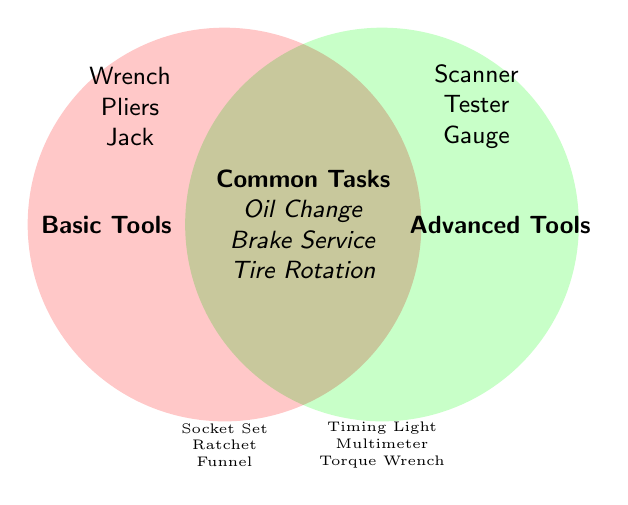Which tools are listed under Basic Tools? The tools under Basic Tools are listed on the left circle of the Venn Diagram, which are Wrench, Pliers, Jack, Socket Set, Ratchet, and Funnel.
Answer: Wrench, Pliers, Jack, Socket Set, Ratchet, Funnel Which tools are listed under Advanced Tools? The tools under Advanced Tools are listed on the right circle of the Venn Diagram, which are Diagnostic Scanner, Oscilloscope, Compression Tester, Fuel Pressure Gauge, Timing Light, Multimeter, and Torque Wrench.
Answer: Diagnostic Scanner, Oscilloscope, Compression Tester, Fuel Pressure Gauge, Timing Light, Multimeter, Torque Wrench What are the common maintenance tasks that overlap between Basic Tools and Advanced Tools? The common tasks are listed in the intersection of the two circles, which are Oil Change, Brake Service, Tire Rotation, Battery Check, Fluid Top-up, and Filter Replacement.
Answer: Oil Change, Brake Service, Tire Rotation, Battery Check, Fluid Top-up, Filter Replacement How many maintenance tasks are common between Basic Tools and Advanced Tools? Count the number of tasks in the intersection of the two circles. There are six tasks listed.
Answer: 6 What tool is required for an Oil Change? Check the common tasks listed in the intersection and match with the tools. The intersection lists Oil Change, which indicates that it requires both basic and advanced tools.
Answer: Both Basic & Advanced Tools Are there more tools listed under Basic Tools or Advanced Tools? Count the number of tools in each circle. Basic Tools have six tools; Advanced Tools have seven tools. Therefore, Advanced Tools have more.
Answer: Advanced Tools Which tool sets share the task of Brake Service? Brake Service is listed in the intersection area of the Venn Diagram, indicating it requires tools from both Basic Tools and Advanced Tools.
Answer: Both Basic & Advanced Tools What tools intersect in the Venn Diagram? There are no tools in the intersection part of the Venn Diagram, as the intersection only lists common maintenance tasks.
Answer: None Which maintenance tasks can be performed using only Advanced Tools? Maintenance tasks can be performed using both Basic and Advanced Tools, as listed in the intersection. No task can be performed using exclusively Advanced Tools, as the intersection suggests the tasks require both.
Answer: None Which maintenance tasks can be performed with a Diagnostic Scanner? Since Diagnostic Scanner is under Advanced Tools, any task in the intersection can be performed using a combination of Advanced Tools including a Diagnostic Scanner. These tasks are Oil Change, Brake Service, Tire Rotation, Battery Check, Fluid Top-up, and Filter Replacement.
Answer: Oil Change, Brake Service, Tire Rotation, Battery Check, Fluid Top-up, Filter Replacement 